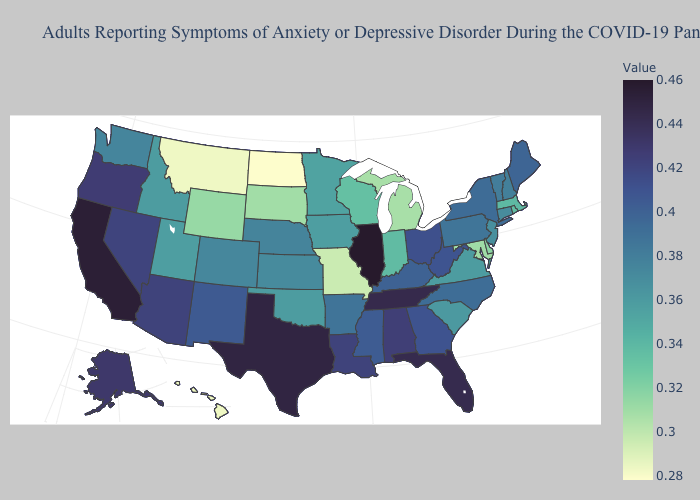Which states have the highest value in the USA?
Keep it brief. Illinois. Does Georgia have a higher value than Nebraska?
Write a very short answer. Yes. Among the states that border Montana , does South Dakota have the lowest value?
Concise answer only. No. Does Montana have the lowest value in the West?
Be succinct. Yes. Among the states that border New York , does Vermont have the lowest value?
Be succinct. No. Does California have the highest value in the West?
Concise answer only. Yes. 